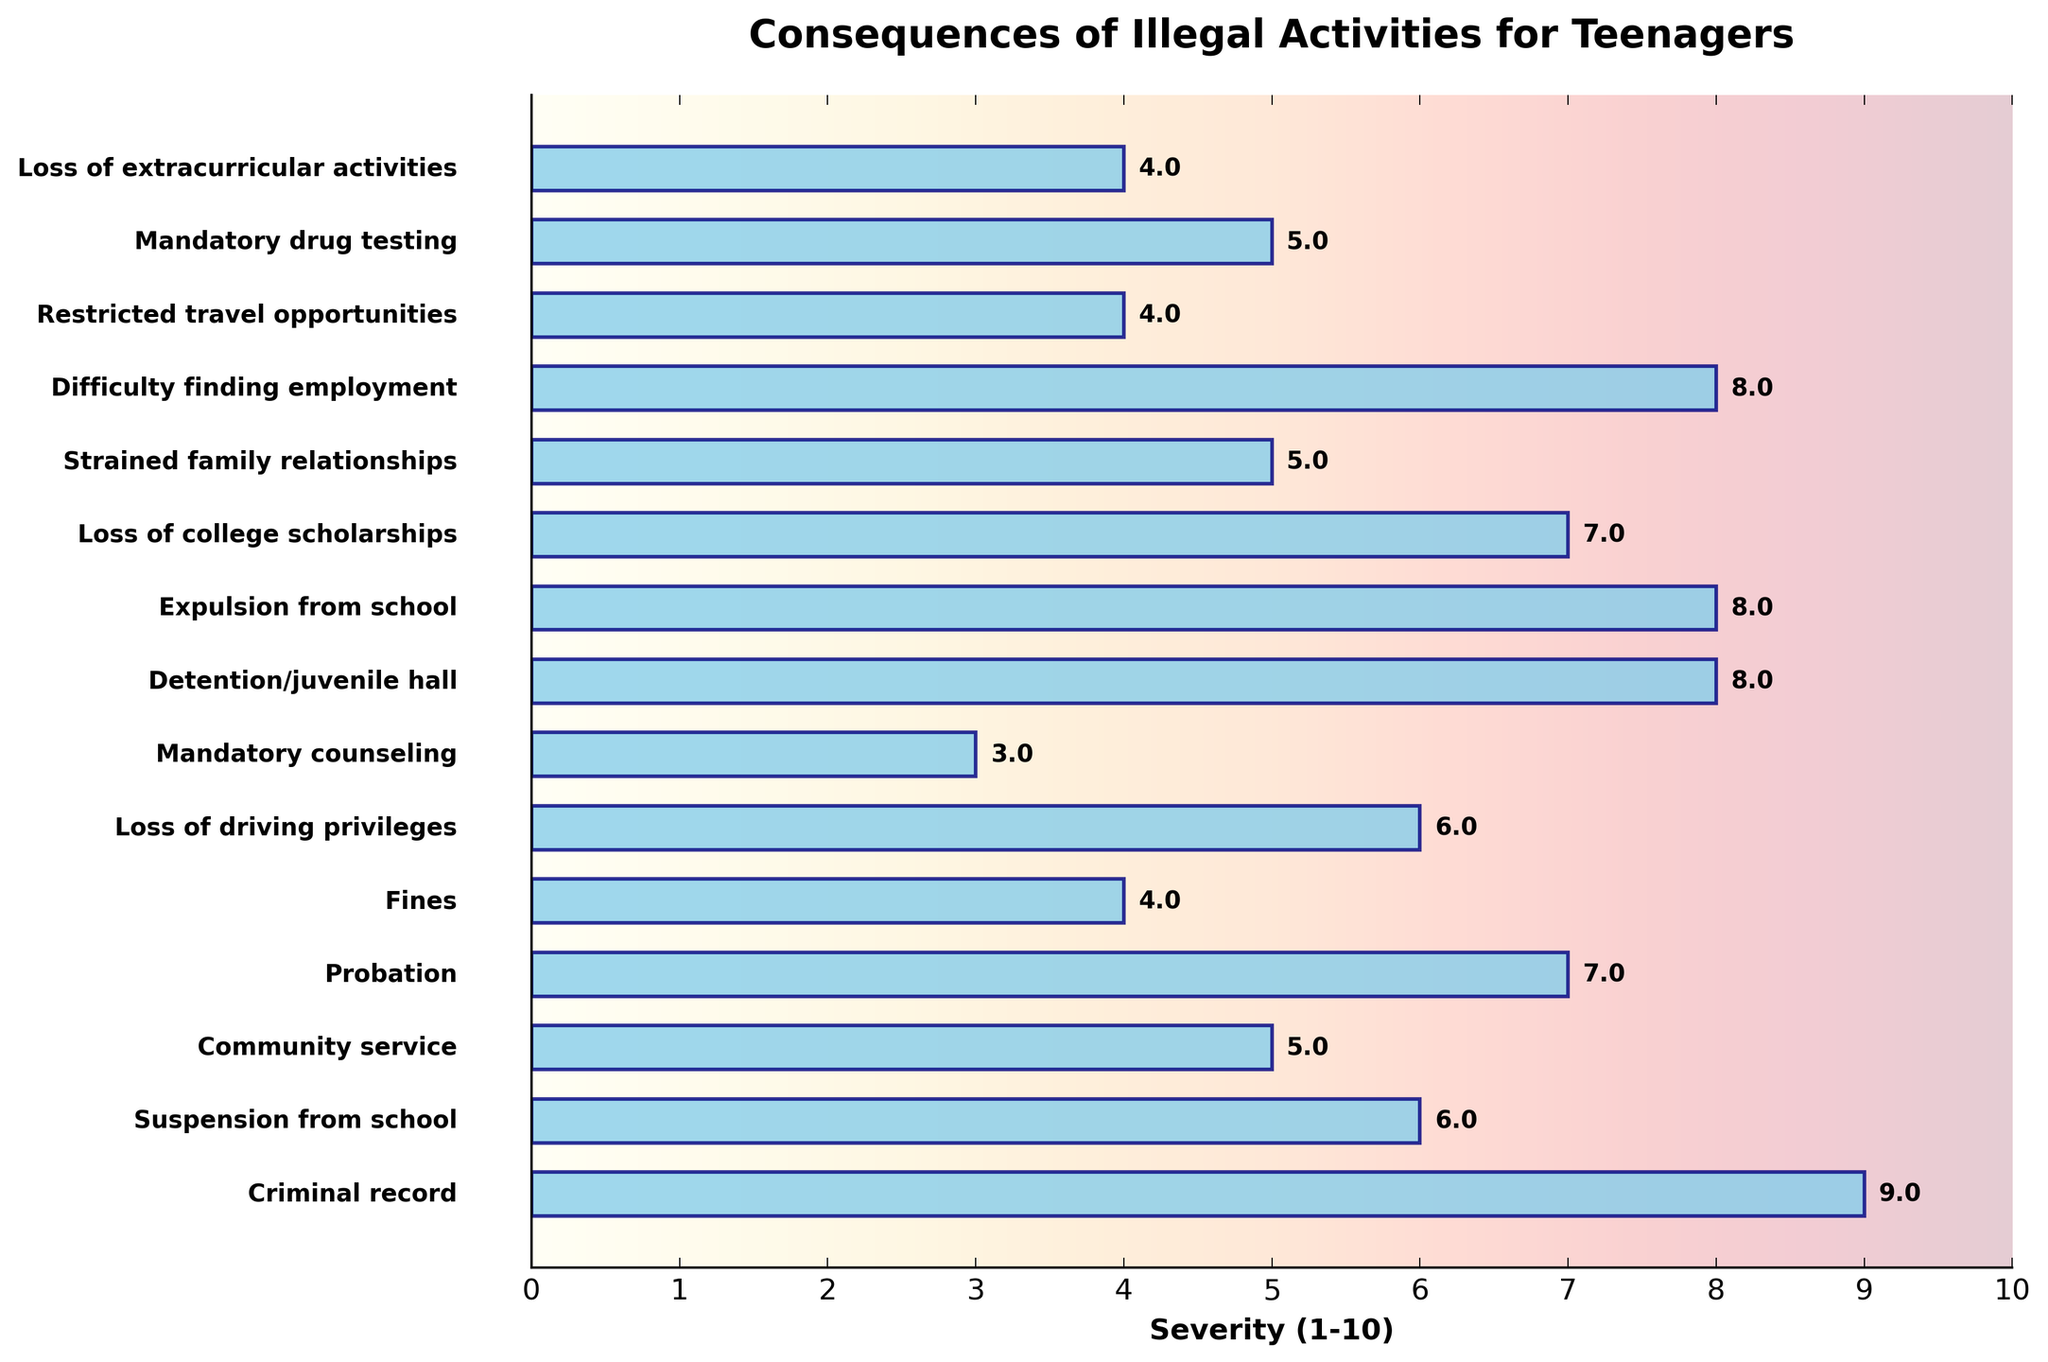Which consequence has the highest severity? The figure shows bars representing the severity of different consequences of illegal activities. The bar for "Criminal record" extends the furthest to the right, indicating it has the highest severity score of 9.
Answer: Criminal record Which consequences have a severity score of 8? The bars labeled "Detention/juvenile hall," "Expulsion from school," and "Difficulty finding employment" all extend to the same point along the severity axis, indicating a severity score of 8.
Answer: Detention/juvenile hall, Expulsion from school, Difficulty finding employment How many consequences have a severity score greater than 6? Count the bars that extend past the severity value of 6. There are 5 such bars: "Criminal record," "Detention/juvenile hall," "Expulsion from school," "Difficulty finding employment," and "Loss of college scholarships."
Answer: 5 What are the consequences with the lowest severity scores? The bars for "Mandatory counseling" and "Mandatory drug testing" extend the least along the severity axis, indicating they have the lowest severity scores of 3 and 5 respectively.
Answer: Mandatory counseling, Mandatory drug testing Compare the severities of "Suspension from school" and "Loss of driving privileges". Which is more severe? The bars for "Suspension from school" and "Loss of driving privileges" both extend to the severity value of 6, making their severities equal.
Answer: Equal How does the severity of "Probation" compare to "Loss of college scholarships"? The bar for "Probation" extends to a severity of 7, while the bar for "Loss of college scholarships" also extends to a severity of 7. Therefore, they are equally severe.
Answer: Equal What is the average severity score for all the consequences listed? Calculate the average by summing all severity scores and dividing by the number of consequences. The sum of severities is 91, and there are 14 consequences. Therefore, the average severity is 91/14 ≈ 6.5.
Answer: 6.5 What is the difference in severity between "Fines" and "Loss of extracurricular activities"? The bar for "Fines" extends to 4, and the bar for "Loss of extracurricular activities" also extends to 4, making the difference 4 - 4 = 0.
Answer: 0 Which consequence is less severe, "Community service" or "Strained family relationships"? The bar for "Community service" extends to 5, while the bar for "Strained family relationships" also extends to 5. Therefore, their severities are equal.
Answer: Equal Visually, which consequence appears in the middle of the severity ranking? "Loss of driving privileges" and "Suspension from school," both with a severity of 6, appear in the middle when viewing the chart from top to bottom.
Answer: Loss of driving privileges, Suspension from school 